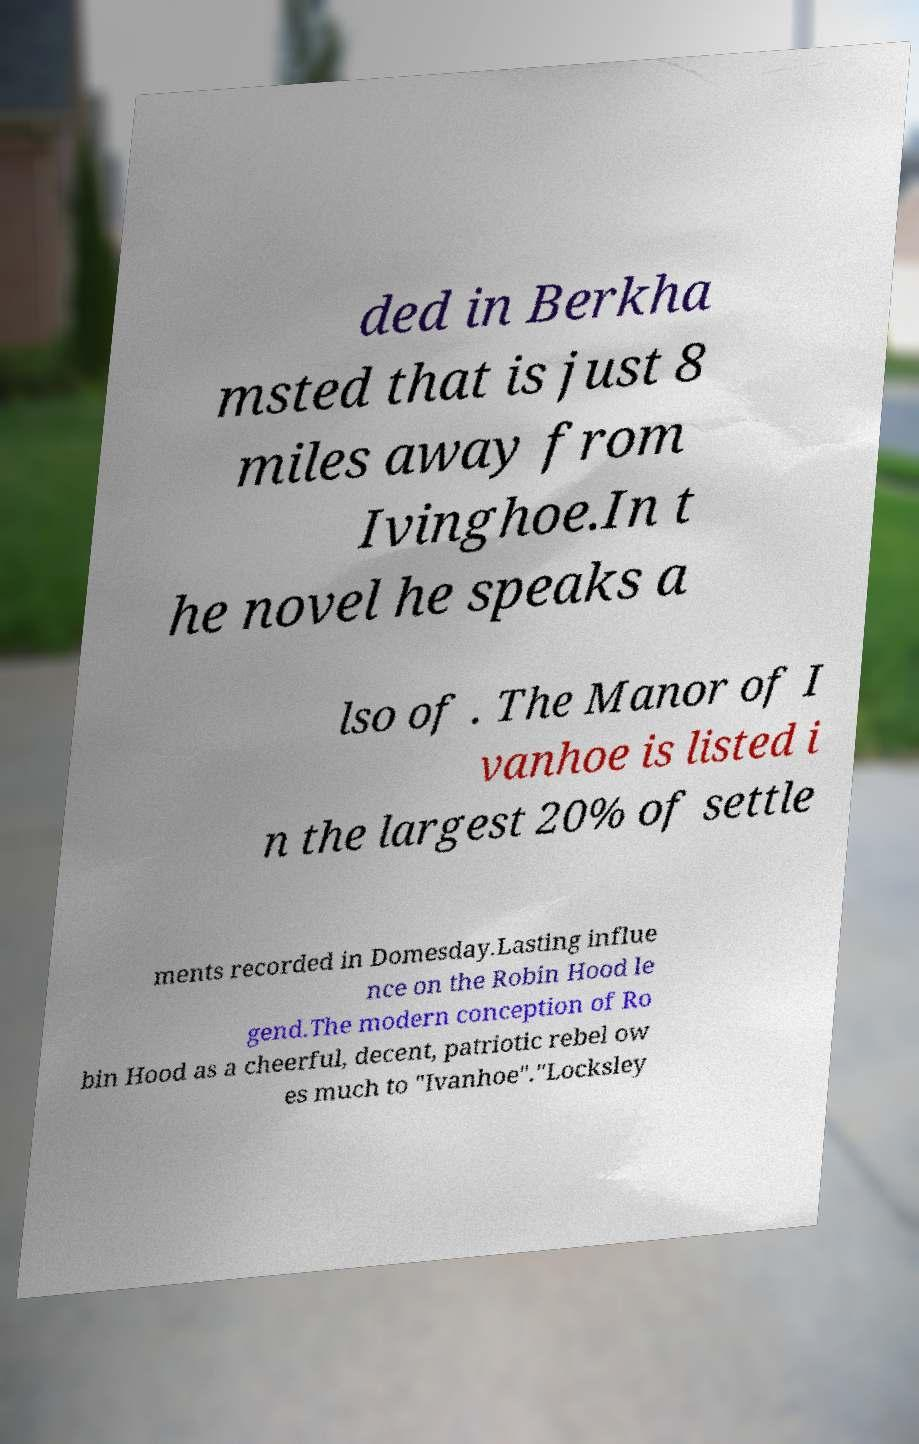Please identify and transcribe the text found in this image. ded in Berkha msted that is just 8 miles away from Ivinghoe.In t he novel he speaks a lso of . The Manor of I vanhoe is listed i n the largest 20% of settle ments recorded in Domesday.Lasting influe nce on the Robin Hood le gend.The modern conception of Ro bin Hood as a cheerful, decent, patriotic rebel ow es much to "Ivanhoe"."Locksley 